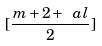Convert formula to latex. <formula><loc_0><loc_0><loc_500><loc_500>[ \frac { m + 2 + \ a l } 2 ]</formula> 